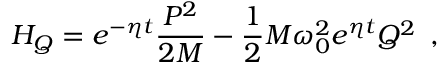Convert formula to latex. <formula><loc_0><loc_0><loc_500><loc_500>H _ { Q } = e ^ { - \eta t } \frac { P ^ { 2 } } { 2 M } - \frac { 1 } { 2 } M \omega _ { 0 } ^ { 2 } e ^ { \eta t } Q ^ { 2 } \, ,</formula> 